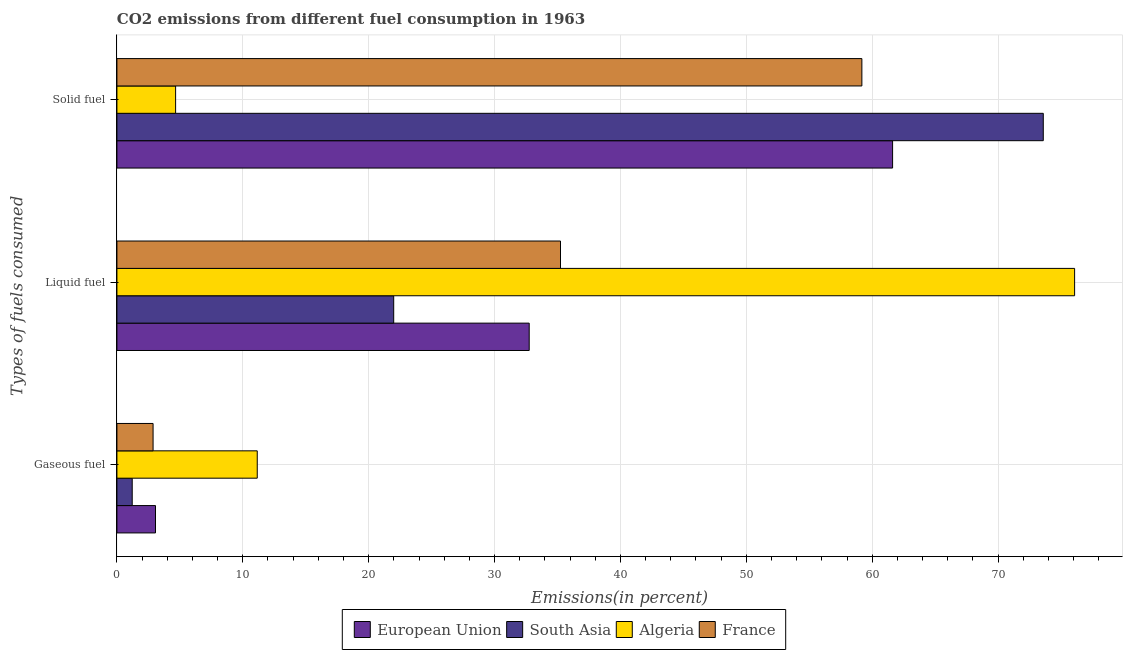How many different coloured bars are there?
Your response must be concise. 4. How many bars are there on the 1st tick from the bottom?
Your response must be concise. 4. What is the label of the 3rd group of bars from the top?
Your answer should be compact. Gaseous fuel. What is the percentage of gaseous fuel emission in European Union?
Make the answer very short. 3.06. Across all countries, what is the maximum percentage of gaseous fuel emission?
Give a very brief answer. 11.15. Across all countries, what is the minimum percentage of solid fuel emission?
Make the answer very short. 4.66. In which country was the percentage of gaseous fuel emission maximum?
Offer a terse response. Algeria. In which country was the percentage of solid fuel emission minimum?
Your response must be concise. Algeria. What is the total percentage of gaseous fuel emission in the graph?
Provide a short and direct response. 18.3. What is the difference between the percentage of liquid fuel emission in Algeria and that in European Union?
Provide a short and direct response. 43.33. What is the difference between the percentage of gaseous fuel emission in South Asia and the percentage of solid fuel emission in Algeria?
Provide a short and direct response. -3.45. What is the average percentage of solid fuel emission per country?
Your response must be concise. 49.76. What is the difference between the percentage of gaseous fuel emission and percentage of solid fuel emission in France?
Provide a short and direct response. -56.31. What is the ratio of the percentage of liquid fuel emission in France to that in South Asia?
Provide a short and direct response. 1.6. What is the difference between the highest and the second highest percentage of solid fuel emission?
Give a very brief answer. 11.97. What is the difference between the highest and the lowest percentage of gaseous fuel emission?
Provide a succinct answer. 9.93. Is the sum of the percentage of solid fuel emission in European Union and South Asia greater than the maximum percentage of gaseous fuel emission across all countries?
Your response must be concise. Yes. What does the 1st bar from the top in Liquid fuel represents?
Your response must be concise. France. What does the 3rd bar from the bottom in Liquid fuel represents?
Provide a short and direct response. Algeria. Is it the case that in every country, the sum of the percentage of gaseous fuel emission and percentage of liquid fuel emission is greater than the percentage of solid fuel emission?
Give a very brief answer. No. How many bars are there?
Keep it short and to the point. 12. Are all the bars in the graph horizontal?
Make the answer very short. Yes. Does the graph contain any zero values?
Ensure brevity in your answer.  No. Does the graph contain grids?
Offer a very short reply. Yes. Where does the legend appear in the graph?
Your answer should be compact. Bottom center. How many legend labels are there?
Ensure brevity in your answer.  4. How are the legend labels stacked?
Your response must be concise. Horizontal. What is the title of the graph?
Provide a short and direct response. CO2 emissions from different fuel consumption in 1963. Does "Sweden" appear as one of the legend labels in the graph?
Ensure brevity in your answer.  No. What is the label or title of the X-axis?
Give a very brief answer. Emissions(in percent). What is the label or title of the Y-axis?
Ensure brevity in your answer.  Types of fuels consumed. What is the Emissions(in percent) of European Union in Gaseous fuel?
Keep it short and to the point. 3.06. What is the Emissions(in percent) in South Asia in Gaseous fuel?
Provide a succinct answer. 1.22. What is the Emissions(in percent) of Algeria in Gaseous fuel?
Offer a very short reply. 11.15. What is the Emissions(in percent) of France in Gaseous fuel?
Your answer should be very brief. 2.87. What is the Emissions(in percent) in European Union in Liquid fuel?
Make the answer very short. 32.75. What is the Emissions(in percent) of South Asia in Liquid fuel?
Your answer should be very brief. 21.99. What is the Emissions(in percent) in Algeria in Liquid fuel?
Your answer should be very brief. 76.08. What is the Emissions(in percent) of France in Liquid fuel?
Provide a short and direct response. 35.24. What is the Emissions(in percent) of European Union in Solid fuel?
Offer a very short reply. 61.62. What is the Emissions(in percent) of South Asia in Solid fuel?
Provide a succinct answer. 73.59. What is the Emissions(in percent) in Algeria in Solid fuel?
Give a very brief answer. 4.66. What is the Emissions(in percent) in France in Solid fuel?
Your answer should be very brief. 59.18. Across all Types of fuels consumed, what is the maximum Emissions(in percent) in European Union?
Your response must be concise. 61.62. Across all Types of fuels consumed, what is the maximum Emissions(in percent) in South Asia?
Your answer should be very brief. 73.59. Across all Types of fuels consumed, what is the maximum Emissions(in percent) in Algeria?
Your answer should be compact. 76.08. Across all Types of fuels consumed, what is the maximum Emissions(in percent) of France?
Provide a succinct answer. 59.18. Across all Types of fuels consumed, what is the minimum Emissions(in percent) in European Union?
Keep it short and to the point. 3.06. Across all Types of fuels consumed, what is the minimum Emissions(in percent) in South Asia?
Keep it short and to the point. 1.22. Across all Types of fuels consumed, what is the minimum Emissions(in percent) of Algeria?
Offer a terse response. 4.66. Across all Types of fuels consumed, what is the minimum Emissions(in percent) of France?
Make the answer very short. 2.87. What is the total Emissions(in percent) of European Union in the graph?
Your response must be concise. 97.44. What is the total Emissions(in percent) in South Asia in the graph?
Keep it short and to the point. 96.8. What is the total Emissions(in percent) in Algeria in the graph?
Keep it short and to the point. 91.89. What is the total Emissions(in percent) in France in the graph?
Keep it short and to the point. 97.29. What is the difference between the Emissions(in percent) of European Union in Gaseous fuel and that in Liquid fuel?
Ensure brevity in your answer.  -29.69. What is the difference between the Emissions(in percent) in South Asia in Gaseous fuel and that in Liquid fuel?
Your answer should be compact. -20.77. What is the difference between the Emissions(in percent) of Algeria in Gaseous fuel and that in Liquid fuel?
Offer a very short reply. -64.93. What is the difference between the Emissions(in percent) in France in Gaseous fuel and that in Liquid fuel?
Provide a succinct answer. -32.37. What is the difference between the Emissions(in percent) in European Union in Gaseous fuel and that in Solid fuel?
Offer a very short reply. -58.56. What is the difference between the Emissions(in percent) of South Asia in Gaseous fuel and that in Solid fuel?
Your response must be concise. -72.38. What is the difference between the Emissions(in percent) of Algeria in Gaseous fuel and that in Solid fuel?
Make the answer very short. 6.49. What is the difference between the Emissions(in percent) of France in Gaseous fuel and that in Solid fuel?
Ensure brevity in your answer.  -56.31. What is the difference between the Emissions(in percent) in European Union in Liquid fuel and that in Solid fuel?
Offer a very short reply. -28.87. What is the difference between the Emissions(in percent) in South Asia in Liquid fuel and that in Solid fuel?
Your response must be concise. -51.6. What is the difference between the Emissions(in percent) of Algeria in Liquid fuel and that in Solid fuel?
Provide a succinct answer. 71.42. What is the difference between the Emissions(in percent) of France in Liquid fuel and that in Solid fuel?
Your response must be concise. -23.94. What is the difference between the Emissions(in percent) of European Union in Gaseous fuel and the Emissions(in percent) of South Asia in Liquid fuel?
Your answer should be compact. -18.92. What is the difference between the Emissions(in percent) in European Union in Gaseous fuel and the Emissions(in percent) in Algeria in Liquid fuel?
Keep it short and to the point. -73.02. What is the difference between the Emissions(in percent) of European Union in Gaseous fuel and the Emissions(in percent) of France in Liquid fuel?
Make the answer very short. -32.17. What is the difference between the Emissions(in percent) of South Asia in Gaseous fuel and the Emissions(in percent) of Algeria in Liquid fuel?
Give a very brief answer. -74.87. What is the difference between the Emissions(in percent) of South Asia in Gaseous fuel and the Emissions(in percent) of France in Liquid fuel?
Give a very brief answer. -34.02. What is the difference between the Emissions(in percent) in Algeria in Gaseous fuel and the Emissions(in percent) in France in Liquid fuel?
Offer a terse response. -24.09. What is the difference between the Emissions(in percent) of European Union in Gaseous fuel and the Emissions(in percent) of South Asia in Solid fuel?
Your answer should be very brief. -70.53. What is the difference between the Emissions(in percent) in European Union in Gaseous fuel and the Emissions(in percent) in Algeria in Solid fuel?
Your answer should be compact. -1.6. What is the difference between the Emissions(in percent) of European Union in Gaseous fuel and the Emissions(in percent) of France in Solid fuel?
Keep it short and to the point. -56.12. What is the difference between the Emissions(in percent) of South Asia in Gaseous fuel and the Emissions(in percent) of Algeria in Solid fuel?
Offer a terse response. -3.45. What is the difference between the Emissions(in percent) in South Asia in Gaseous fuel and the Emissions(in percent) in France in Solid fuel?
Keep it short and to the point. -57.97. What is the difference between the Emissions(in percent) of Algeria in Gaseous fuel and the Emissions(in percent) of France in Solid fuel?
Offer a terse response. -48.03. What is the difference between the Emissions(in percent) of European Union in Liquid fuel and the Emissions(in percent) of South Asia in Solid fuel?
Keep it short and to the point. -40.84. What is the difference between the Emissions(in percent) in European Union in Liquid fuel and the Emissions(in percent) in Algeria in Solid fuel?
Ensure brevity in your answer.  28.09. What is the difference between the Emissions(in percent) of European Union in Liquid fuel and the Emissions(in percent) of France in Solid fuel?
Your answer should be very brief. -26.43. What is the difference between the Emissions(in percent) in South Asia in Liquid fuel and the Emissions(in percent) in Algeria in Solid fuel?
Your answer should be compact. 17.33. What is the difference between the Emissions(in percent) in South Asia in Liquid fuel and the Emissions(in percent) in France in Solid fuel?
Give a very brief answer. -37.19. What is the difference between the Emissions(in percent) in Algeria in Liquid fuel and the Emissions(in percent) in France in Solid fuel?
Your response must be concise. 16.9. What is the average Emissions(in percent) of European Union per Types of fuels consumed?
Provide a succinct answer. 32.48. What is the average Emissions(in percent) of South Asia per Types of fuels consumed?
Keep it short and to the point. 32.27. What is the average Emissions(in percent) of Algeria per Types of fuels consumed?
Your answer should be very brief. 30.63. What is the average Emissions(in percent) of France per Types of fuels consumed?
Offer a terse response. 32.43. What is the difference between the Emissions(in percent) in European Union and Emissions(in percent) in South Asia in Gaseous fuel?
Your answer should be compact. 1.85. What is the difference between the Emissions(in percent) in European Union and Emissions(in percent) in Algeria in Gaseous fuel?
Make the answer very short. -8.08. What is the difference between the Emissions(in percent) of European Union and Emissions(in percent) of France in Gaseous fuel?
Your answer should be compact. 0.19. What is the difference between the Emissions(in percent) of South Asia and Emissions(in percent) of Algeria in Gaseous fuel?
Give a very brief answer. -9.93. What is the difference between the Emissions(in percent) of South Asia and Emissions(in percent) of France in Gaseous fuel?
Ensure brevity in your answer.  -1.66. What is the difference between the Emissions(in percent) of Algeria and Emissions(in percent) of France in Gaseous fuel?
Your answer should be very brief. 8.28. What is the difference between the Emissions(in percent) in European Union and Emissions(in percent) in South Asia in Liquid fuel?
Your answer should be very brief. 10.76. What is the difference between the Emissions(in percent) of European Union and Emissions(in percent) of Algeria in Liquid fuel?
Ensure brevity in your answer.  -43.33. What is the difference between the Emissions(in percent) of European Union and Emissions(in percent) of France in Liquid fuel?
Offer a terse response. -2.49. What is the difference between the Emissions(in percent) of South Asia and Emissions(in percent) of Algeria in Liquid fuel?
Offer a terse response. -54.09. What is the difference between the Emissions(in percent) in South Asia and Emissions(in percent) in France in Liquid fuel?
Your response must be concise. -13.25. What is the difference between the Emissions(in percent) of Algeria and Emissions(in percent) of France in Liquid fuel?
Your answer should be very brief. 40.84. What is the difference between the Emissions(in percent) in European Union and Emissions(in percent) in South Asia in Solid fuel?
Provide a succinct answer. -11.97. What is the difference between the Emissions(in percent) of European Union and Emissions(in percent) of Algeria in Solid fuel?
Offer a terse response. 56.96. What is the difference between the Emissions(in percent) of European Union and Emissions(in percent) of France in Solid fuel?
Provide a succinct answer. 2.44. What is the difference between the Emissions(in percent) in South Asia and Emissions(in percent) in Algeria in Solid fuel?
Offer a very short reply. 68.93. What is the difference between the Emissions(in percent) of South Asia and Emissions(in percent) of France in Solid fuel?
Provide a short and direct response. 14.41. What is the difference between the Emissions(in percent) in Algeria and Emissions(in percent) in France in Solid fuel?
Offer a terse response. -54.52. What is the ratio of the Emissions(in percent) of European Union in Gaseous fuel to that in Liquid fuel?
Provide a short and direct response. 0.09. What is the ratio of the Emissions(in percent) in South Asia in Gaseous fuel to that in Liquid fuel?
Your response must be concise. 0.06. What is the ratio of the Emissions(in percent) in Algeria in Gaseous fuel to that in Liquid fuel?
Your response must be concise. 0.15. What is the ratio of the Emissions(in percent) of France in Gaseous fuel to that in Liquid fuel?
Provide a short and direct response. 0.08. What is the ratio of the Emissions(in percent) in European Union in Gaseous fuel to that in Solid fuel?
Give a very brief answer. 0.05. What is the ratio of the Emissions(in percent) of South Asia in Gaseous fuel to that in Solid fuel?
Give a very brief answer. 0.02. What is the ratio of the Emissions(in percent) of Algeria in Gaseous fuel to that in Solid fuel?
Give a very brief answer. 2.39. What is the ratio of the Emissions(in percent) of France in Gaseous fuel to that in Solid fuel?
Provide a succinct answer. 0.05. What is the ratio of the Emissions(in percent) of European Union in Liquid fuel to that in Solid fuel?
Your answer should be very brief. 0.53. What is the ratio of the Emissions(in percent) of South Asia in Liquid fuel to that in Solid fuel?
Offer a very short reply. 0.3. What is the ratio of the Emissions(in percent) in Algeria in Liquid fuel to that in Solid fuel?
Your response must be concise. 16.32. What is the ratio of the Emissions(in percent) of France in Liquid fuel to that in Solid fuel?
Keep it short and to the point. 0.6. What is the difference between the highest and the second highest Emissions(in percent) in European Union?
Provide a short and direct response. 28.87. What is the difference between the highest and the second highest Emissions(in percent) of South Asia?
Offer a very short reply. 51.6. What is the difference between the highest and the second highest Emissions(in percent) in Algeria?
Offer a very short reply. 64.93. What is the difference between the highest and the second highest Emissions(in percent) in France?
Offer a terse response. 23.94. What is the difference between the highest and the lowest Emissions(in percent) of European Union?
Keep it short and to the point. 58.56. What is the difference between the highest and the lowest Emissions(in percent) of South Asia?
Your answer should be very brief. 72.38. What is the difference between the highest and the lowest Emissions(in percent) of Algeria?
Provide a short and direct response. 71.42. What is the difference between the highest and the lowest Emissions(in percent) of France?
Your answer should be very brief. 56.31. 